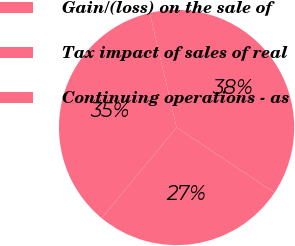Convert chart. <chart><loc_0><loc_0><loc_500><loc_500><pie_chart><fcel>Gain/(loss) on the sale of<fcel>Tax impact of sales of real<fcel>Continuing operations - as<nl><fcel>35.34%<fcel>38.01%<fcel>26.65%<nl></chart> 